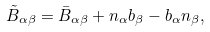<formula> <loc_0><loc_0><loc_500><loc_500>\tilde { B } _ { \alpha \beta } = \bar { B } _ { \alpha \beta } + n _ { \alpha } b _ { \beta } - b _ { \alpha } n _ { \beta } ,</formula> 